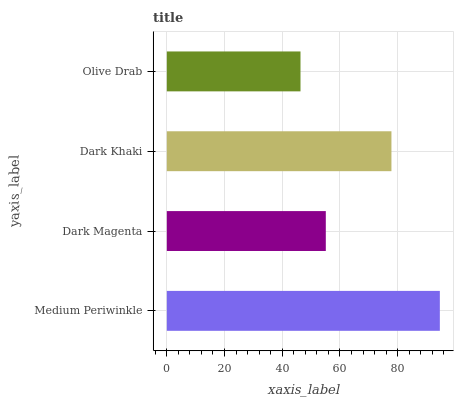Is Olive Drab the minimum?
Answer yes or no. Yes. Is Medium Periwinkle the maximum?
Answer yes or no. Yes. Is Dark Magenta the minimum?
Answer yes or no. No. Is Dark Magenta the maximum?
Answer yes or no. No. Is Medium Periwinkle greater than Dark Magenta?
Answer yes or no. Yes. Is Dark Magenta less than Medium Periwinkle?
Answer yes or no. Yes. Is Dark Magenta greater than Medium Periwinkle?
Answer yes or no. No. Is Medium Periwinkle less than Dark Magenta?
Answer yes or no. No. Is Dark Khaki the high median?
Answer yes or no. Yes. Is Dark Magenta the low median?
Answer yes or no. Yes. Is Dark Magenta the high median?
Answer yes or no. No. Is Dark Khaki the low median?
Answer yes or no. No. 